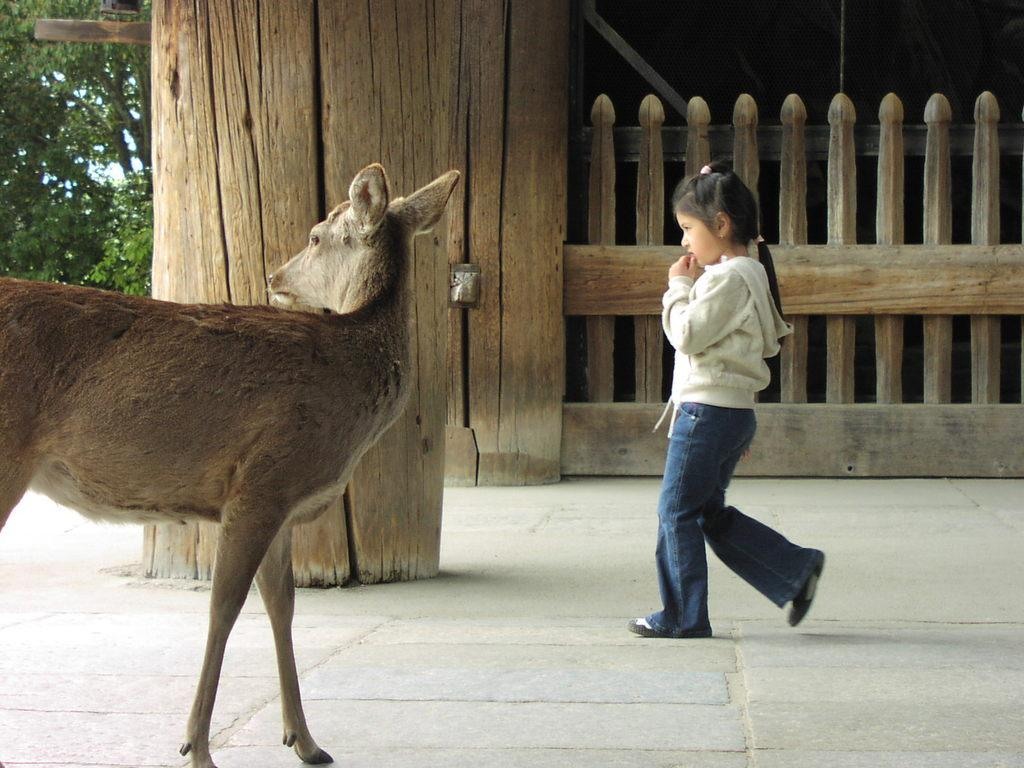What animal can be seen on the left side of the image? There is a deer on the left side of the image. What is the main subject in the middle of the image? There is a girl in the middle of the image. What type of vegetation is visible in the background of the image? There are trees in the background of the image. What type of architectural feature can be seen in the background of the image? There is wooden fencing in the background of the image. How many eggs are being laid by the hen in the image? There is no hen or eggs present in the image. What type of wall is visible in the image? There is no wall visible in the image; it features a deer, a girl, trees, and wooden fencing. 